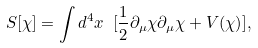<formula> <loc_0><loc_0><loc_500><loc_500>S [ \chi ] = \int d ^ { 4 } x \ [ \frac { 1 } { 2 } \partial _ { \mu } \chi \partial _ { \mu } \chi + V ( \chi ) ] ,</formula> 